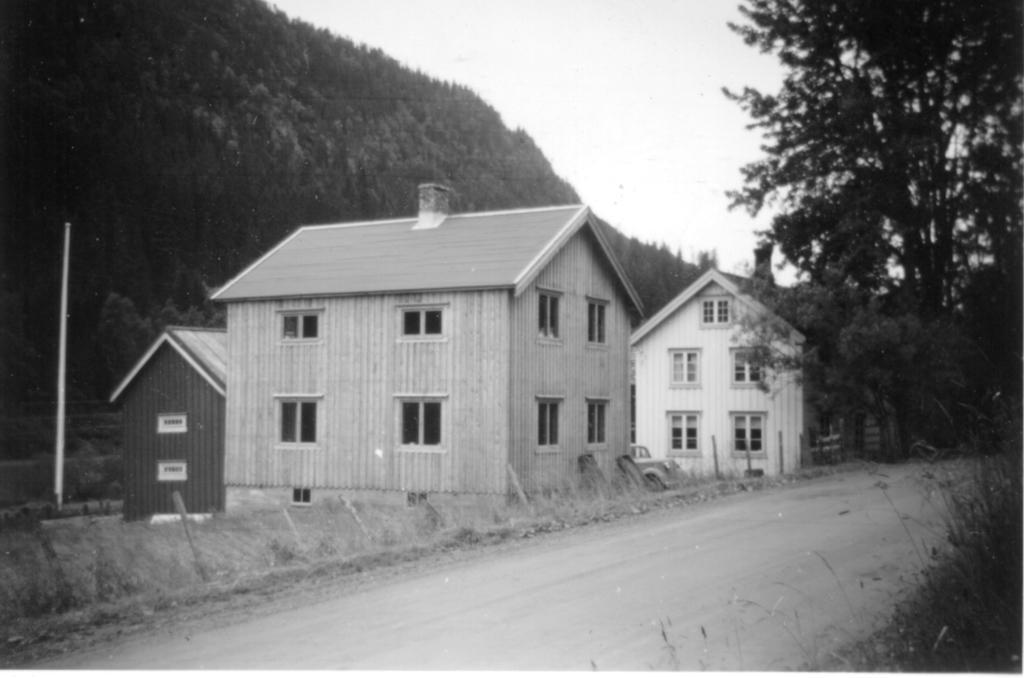Can you describe this image briefly? This is a black and white picture. In this picture we can see the sky, trees, houses, pole, plants, road and few objects. 